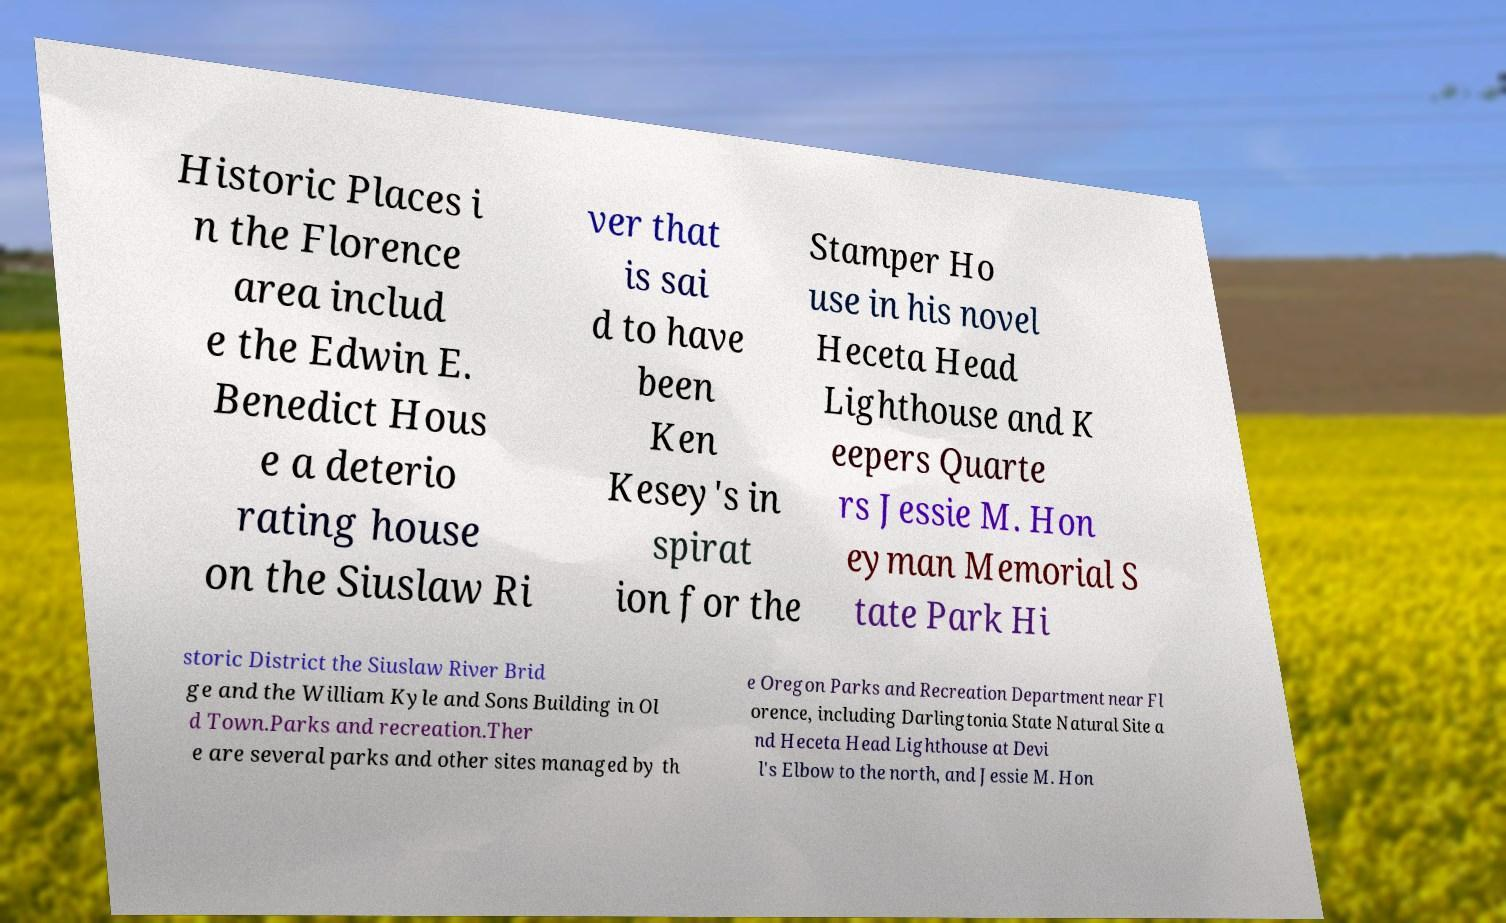What messages or text are displayed in this image? I need them in a readable, typed format. Historic Places i n the Florence area includ e the Edwin E. Benedict Hous e a deterio rating house on the Siuslaw Ri ver that is sai d to have been Ken Kesey's in spirat ion for the Stamper Ho use in his novel Heceta Head Lighthouse and K eepers Quarte rs Jessie M. Hon eyman Memorial S tate Park Hi storic District the Siuslaw River Brid ge and the William Kyle and Sons Building in Ol d Town.Parks and recreation.Ther e are several parks and other sites managed by th e Oregon Parks and Recreation Department near Fl orence, including Darlingtonia State Natural Site a nd Heceta Head Lighthouse at Devi l's Elbow to the north, and Jessie M. Hon 